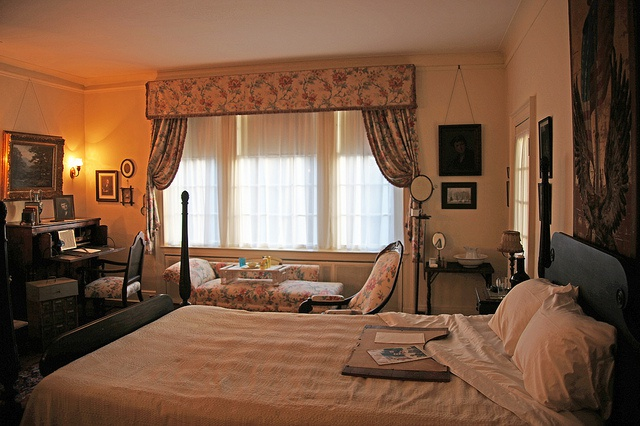Describe the objects in this image and their specific colors. I can see bed in maroon, brown, and tan tones, couch in maroon, brown, and darkgray tones, chair in maroon, brown, and black tones, chair in maroon, black, and gray tones, and bowl in maroon, gray, and brown tones in this image. 